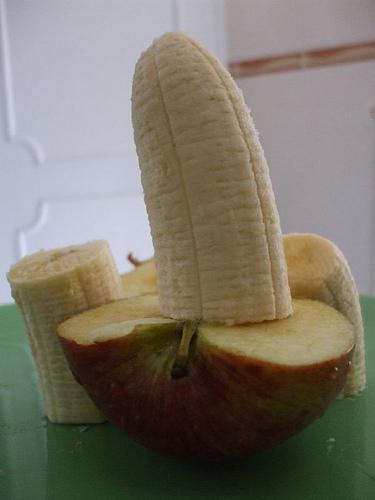What is on the apple?
Give a very brief answer. Banana. Is the middle or the end of the banana on top of the apple?
Keep it brief. End. What is the apple for?
Quick response, please. Eating. 